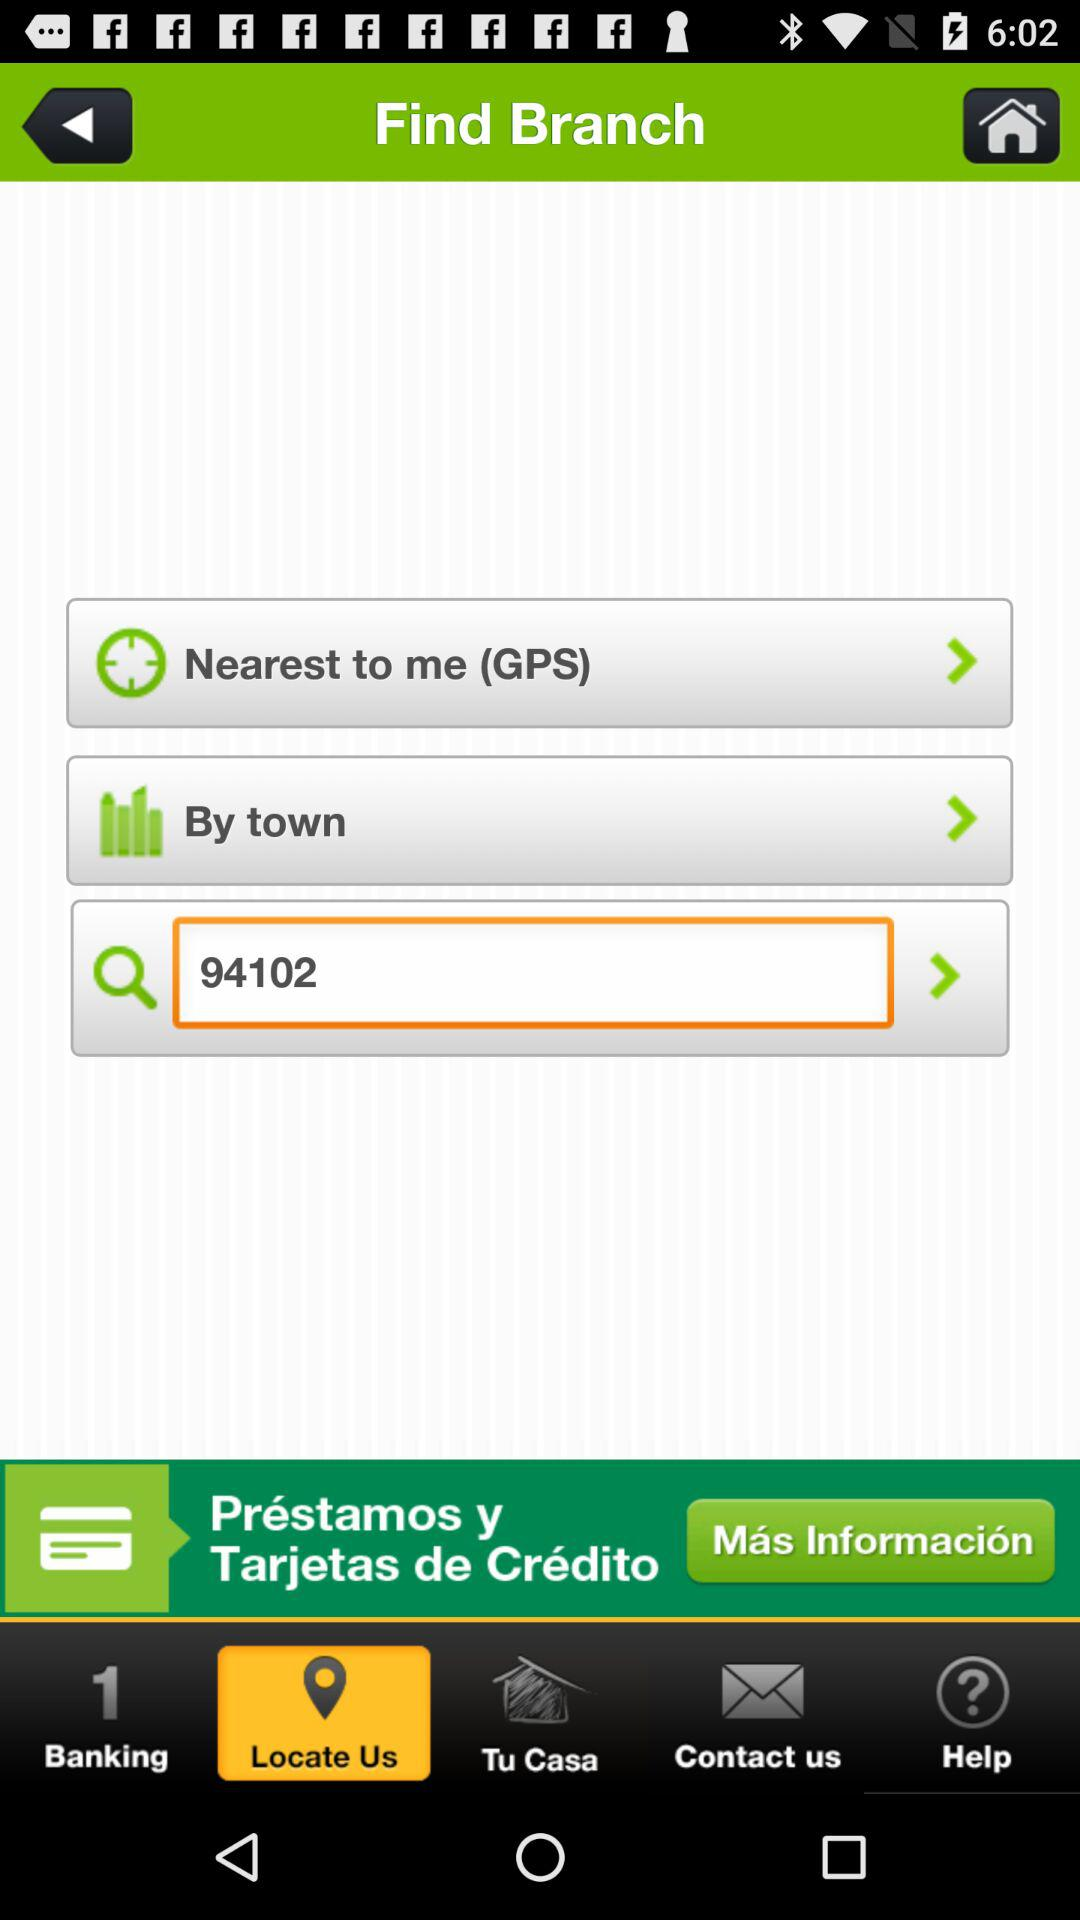What is the selected branch?
When the provided information is insufficient, respond with <no answer>. <no answer> 